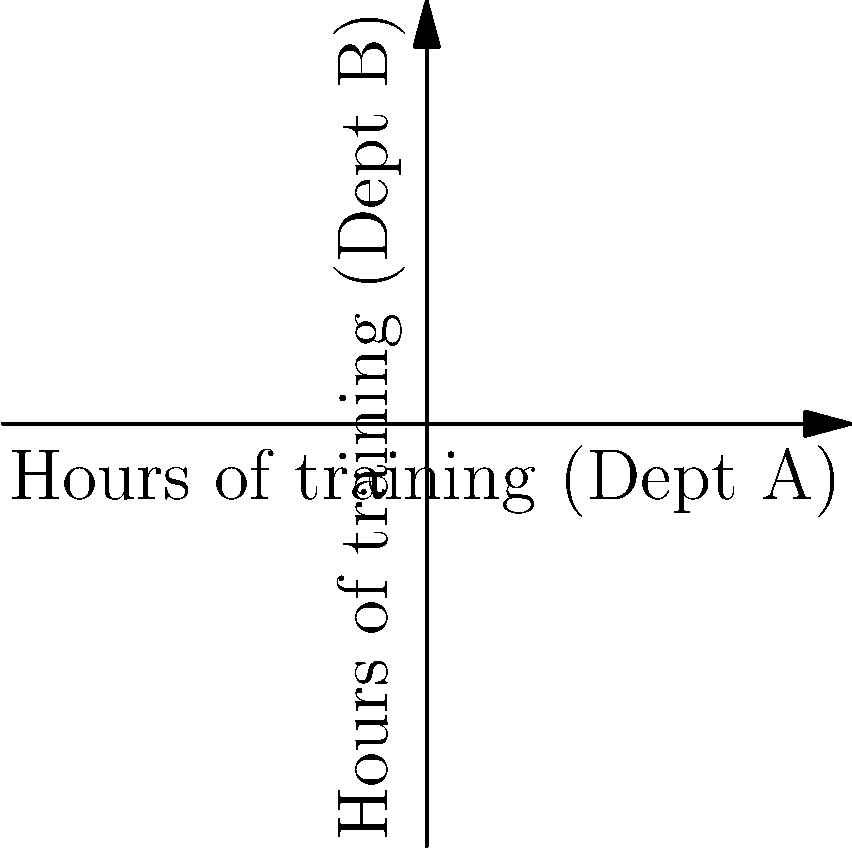As a budget manager, you need to allocate training funds between two departments, A and B. The constraints are:

1. Total training hours cannot exceed 100: $x + y \leq 100$
2. Department B requires at least half the hours of Department A: $y \geq 0.5x$
3. Department B needs at least 20 hours of training: $y \geq 20$

Where $x$ represents hours for Department A and $y$ represents hours for Department B.

If the goal is to maximize total training hours, how many hours should be allocated to each department? To solve this problem, we'll follow these steps:

1) First, we identify the feasible region by plotting the constraints:
   - $x + y = 100$ (blue line)
   - $y = 0.5x$ (red line)
   - $y = 20$ (implicit horizontal line)

2) The feasible region is the area that satisfies all constraints simultaneously.

3) The optimal solution will be at one of the vertices of this feasible region. The vertices are:
   - (0, 60)
   - (40, 60)
   - (80, 20)
   - (100, 0) [not feasible as it doesn't meet the $y \geq 20$ constraint]

4) To maximize total training hours, we want to find the point that gives the largest sum of $x + y$.

5) Calculating total hours for each feasible vertex:
   - (0, 60): 0 + 60 = 60 hours
   - (40, 60): 40 + 60 = 100 hours
   - (80, 20): 80 + 20 = 100 hours

6) Both (40, 60) and (80, 20) give the maximum of 100 total training hours.

7) However, the question asks for a single solution. In this case, we can choose (40, 60) as it provides a more balanced distribution between departments.

Therefore, the optimal allocation is 40 hours for Department A and 60 hours for Department B.
Answer: Department A: 40 hours, Department B: 60 hours 